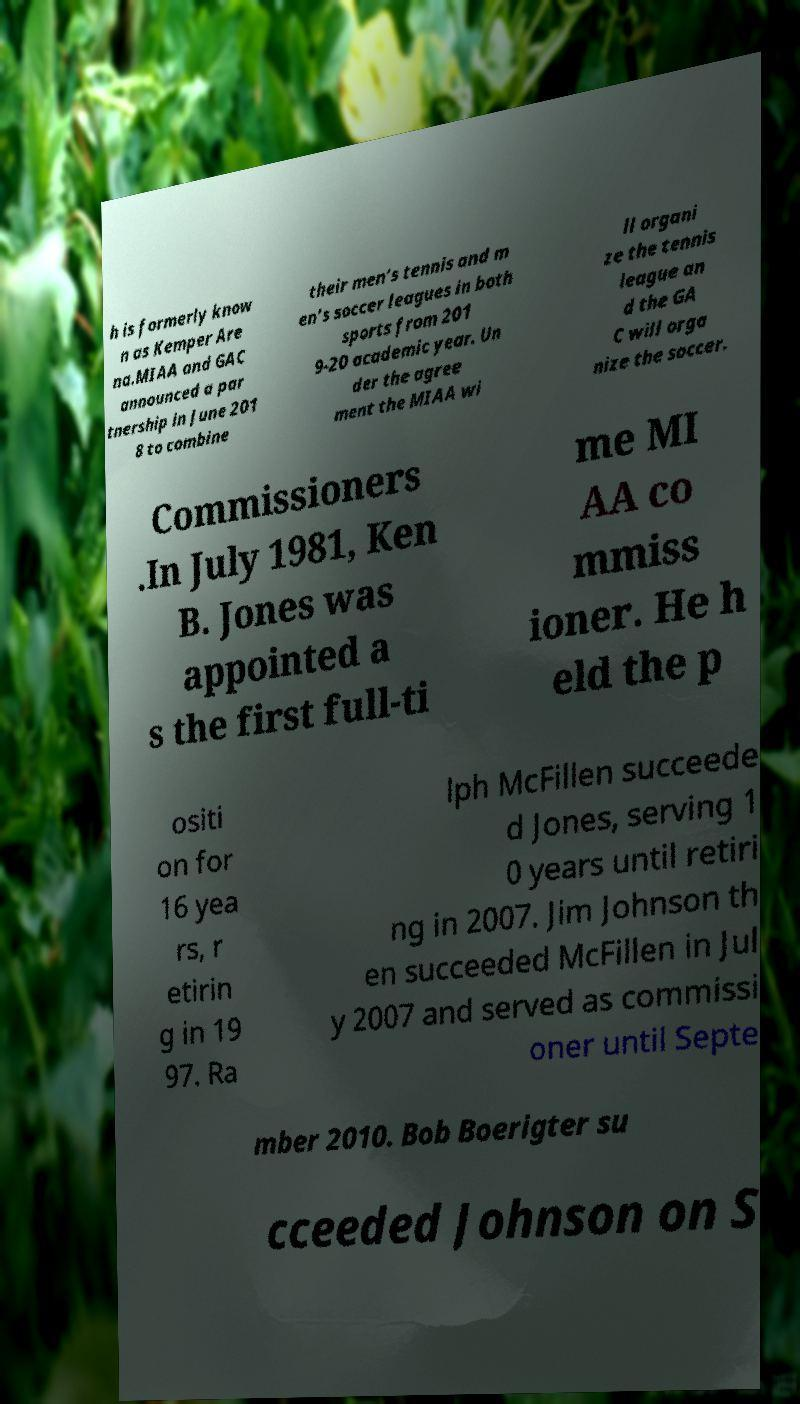Please read and relay the text visible in this image. What does it say? h is formerly know n as Kemper Are na.MIAA and GAC announced a par tnership in June 201 8 to combine their men’s tennis and m en’s soccer leagues in both sports from 201 9-20 academic year. Un der the agree ment the MIAA wi ll organi ze the tennis league an d the GA C will orga nize the soccer. Commissioners .In July 1981, Ken B. Jones was appointed a s the first full-ti me MI AA co mmiss ioner. He h eld the p ositi on for 16 yea rs, r etirin g in 19 97. Ra lph McFillen succeede d Jones, serving 1 0 years until retiri ng in 2007. Jim Johnson th en succeeded McFillen in Jul y 2007 and served as commissi oner until Septe mber 2010. Bob Boerigter su cceeded Johnson on S 